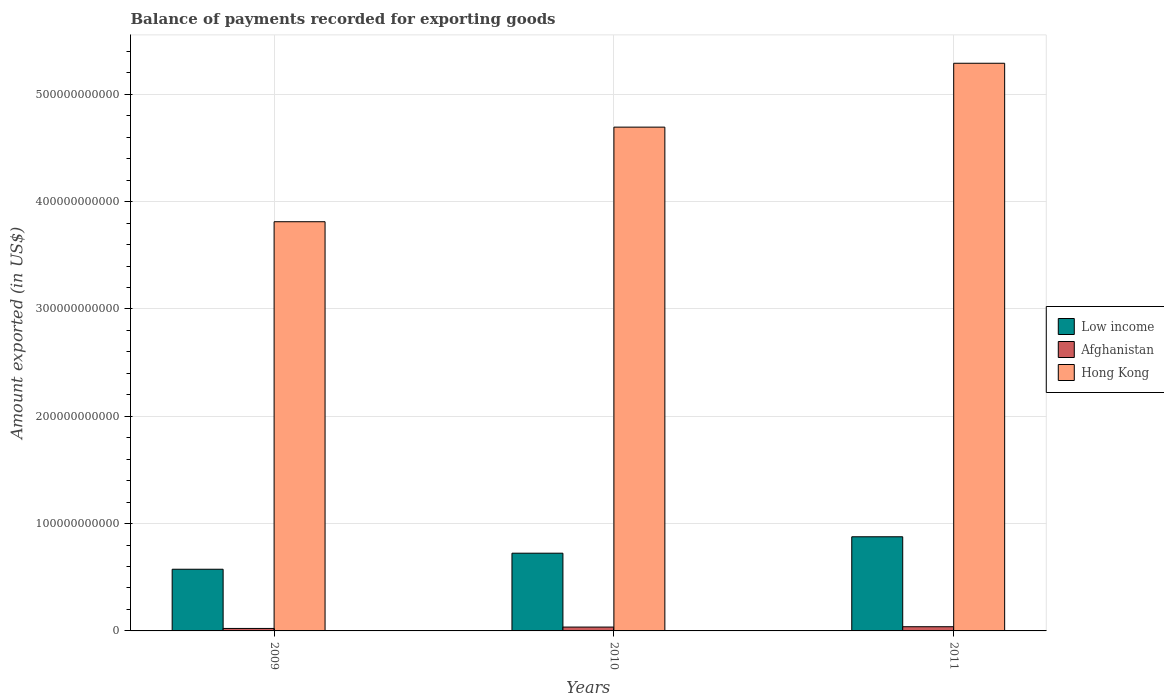How many groups of bars are there?
Keep it short and to the point. 3. How many bars are there on the 2nd tick from the left?
Provide a succinct answer. 3. In how many cases, is the number of bars for a given year not equal to the number of legend labels?
Make the answer very short. 0. What is the amount exported in Hong Kong in 2010?
Your answer should be very brief. 4.69e+11. Across all years, what is the maximum amount exported in Hong Kong?
Give a very brief answer. 5.29e+11. Across all years, what is the minimum amount exported in Hong Kong?
Ensure brevity in your answer.  3.81e+11. What is the total amount exported in Hong Kong in the graph?
Ensure brevity in your answer.  1.38e+12. What is the difference between the amount exported in Hong Kong in 2010 and that in 2011?
Offer a terse response. -5.95e+1. What is the difference between the amount exported in Hong Kong in 2011 and the amount exported in Low income in 2010?
Offer a very short reply. 4.57e+11. What is the average amount exported in Low income per year?
Your response must be concise. 7.25e+1. In the year 2011, what is the difference between the amount exported in Low income and amount exported in Hong Kong?
Make the answer very short. -4.41e+11. In how many years, is the amount exported in Hong Kong greater than 360000000000 US$?
Offer a terse response. 3. What is the ratio of the amount exported in Hong Kong in 2009 to that in 2010?
Your answer should be very brief. 0.81. Is the amount exported in Hong Kong in 2009 less than that in 2011?
Provide a succinct answer. Yes. What is the difference between the highest and the second highest amount exported in Hong Kong?
Make the answer very short. 5.95e+1. What is the difference between the highest and the lowest amount exported in Hong Kong?
Offer a very short reply. 1.48e+11. In how many years, is the amount exported in Hong Kong greater than the average amount exported in Hong Kong taken over all years?
Offer a very short reply. 2. What does the 3rd bar from the left in 2009 represents?
Make the answer very short. Hong Kong. What does the 2nd bar from the right in 2009 represents?
Make the answer very short. Afghanistan. How many bars are there?
Your answer should be very brief. 9. Are all the bars in the graph horizontal?
Your answer should be compact. No. What is the difference between two consecutive major ticks on the Y-axis?
Offer a terse response. 1.00e+11. Does the graph contain grids?
Provide a short and direct response. Yes. Where does the legend appear in the graph?
Ensure brevity in your answer.  Center right. What is the title of the graph?
Your answer should be very brief. Balance of payments recorded for exporting goods. Does "Mongolia" appear as one of the legend labels in the graph?
Your response must be concise. No. What is the label or title of the X-axis?
Your answer should be compact. Years. What is the label or title of the Y-axis?
Your response must be concise. Amount exported (in US$). What is the Amount exported (in US$) of Low income in 2009?
Keep it short and to the point. 5.75e+1. What is the Amount exported (in US$) in Afghanistan in 2009?
Your response must be concise. 2.30e+09. What is the Amount exported (in US$) in Hong Kong in 2009?
Your response must be concise. 3.81e+11. What is the Amount exported (in US$) of Low income in 2010?
Keep it short and to the point. 7.24e+1. What is the Amount exported (in US$) in Afghanistan in 2010?
Ensure brevity in your answer.  3.59e+09. What is the Amount exported (in US$) in Hong Kong in 2010?
Give a very brief answer. 4.69e+11. What is the Amount exported (in US$) in Low income in 2011?
Provide a succinct answer. 8.77e+1. What is the Amount exported (in US$) in Afghanistan in 2011?
Make the answer very short. 3.91e+09. What is the Amount exported (in US$) in Hong Kong in 2011?
Your answer should be very brief. 5.29e+11. Across all years, what is the maximum Amount exported (in US$) in Low income?
Make the answer very short. 8.77e+1. Across all years, what is the maximum Amount exported (in US$) of Afghanistan?
Offer a very short reply. 3.91e+09. Across all years, what is the maximum Amount exported (in US$) of Hong Kong?
Keep it short and to the point. 5.29e+11. Across all years, what is the minimum Amount exported (in US$) of Low income?
Ensure brevity in your answer.  5.75e+1. Across all years, what is the minimum Amount exported (in US$) in Afghanistan?
Give a very brief answer. 2.30e+09. Across all years, what is the minimum Amount exported (in US$) of Hong Kong?
Keep it short and to the point. 3.81e+11. What is the total Amount exported (in US$) in Low income in the graph?
Keep it short and to the point. 2.18e+11. What is the total Amount exported (in US$) in Afghanistan in the graph?
Offer a terse response. 9.80e+09. What is the total Amount exported (in US$) in Hong Kong in the graph?
Ensure brevity in your answer.  1.38e+12. What is the difference between the Amount exported (in US$) in Low income in 2009 and that in 2010?
Give a very brief answer. -1.50e+1. What is the difference between the Amount exported (in US$) of Afghanistan in 2009 and that in 2010?
Make the answer very short. -1.29e+09. What is the difference between the Amount exported (in US$) of Hong Kong in 2009 and that in 2010?
Your answer should be compact. -8.81e+1. What is the difference between the Amount exported (in US$) of Low income in 2009 and that in 2011?
Your answer should be compact. -3.03e+1. What is the difference between the Amount exported (in US$) in Afghanistan in 2009 and that in 2011?
Give a very brief answer. -1.61e+09. What is the difference between the Amount exported (in US$) of Hong Kong in 2009 and that in 2011?
Your answer should be very brief. -1.48e+11. What is the difference between the Amount exported (in US$) of Low income in 2010 and that in 2011?
Give a very brief answer. -1.53e+1. What is the difference between the Amount exported (in US$) of Afghanistan in 2010 and that in 2011?
Your answer should be very brief. -3.13e+08. What is the difference between the Amount exported (in US$) in Hong Kong in 2010 and that in 2011?
Offer a terse response. -5.95e+1. What is the difference between the Amount exported (in US$) in Low income in 2009 and the Amount exported (in US$) in Afghanistan in 2010?
Offer a terse response. 5.39e+1. What is the difference between the Amount exported (in US$) of Low income in 2009 and the Amount exported (in US$) of Hong Kong in 2010?
Keep it short and to the point. -4.12e+11. What is the difference between the Amount exported (in US$) of Afghanistan in 2009 and the Amount exported (in US$) of Hong Kong in 2010?
Your answer should be compact. -4.67e+11. What is the difference between the Amount exported (in US$) of Low income in 2009 and the Amount exported (in US$) of Afghanistan in 2011?
Ensure brevity in your answer.  5.36e+1. What is the difference between the Amount exported (in US$) of Low income in 2009 and the Amount exported (in US$) of Hong Kong in 2011?
Your response must be concise. -4.71e+11. What is the difference between the Amount exported (in US$) of Afghanistan in 2009 and the Amount exported (in US$) of Hong Kong in 2011?
Provide a succinct answer. -5.27e+11. What is the difference between the Amount exported (in US$) in Low income in 2010 and the Amount exported (in US$) in Afghanistan in 2011?
Ensure brevity in your answer.  6.85e+1. What is the difference between the Amount exported (in US$) in Low income in 2010 and the Amount exported (in US$) in Hong Kong in 2011?
Offer a terse response. -4.57e+11. What is the difference between the Amount exported (in US$) of Afghanistan in 2010 and the Amount exported (in US$) of Hong Kong in 2011?
Your answer should be compact. -5.25e+11. What is the average Amount exported (in US$) of Low income per year?
Offer a very short reply. 7.25e+1. What is the average Amount exported (in US$) of Afghanistan per year?
Your answer should be very brief. 3.27e+09. What is the average Amount exported (in US$) in Hong Kong per year?
Give a very brief answer. 4.60e+11. In the year 2009, what is the difference between the Amount exported (in US$) of Low income and Amount exported (in US$) of Afghanistan?
Make the answer very short. 5.52e+1. In the year 2009, what is the difference between the Amount exported (in US$) in Low income and Amount exported (in US$) in Hong Kong?
Your answer should be very brief. -3.24e+11. In the year 2009, what is the difference between the Amount exported (in US$) in Afghanistan and Amount exported (in US$) in Hong Kong?
Provide a succinct answer. -3.79e+11. In the year 2010, what is the difference between the Amount exported (in US$) of Low income and Amount exported (in US$) of Afghanistan?
Your response must be concise. 6.88e+1. In the year 2010, what is the difference between the Amount exported (in US$) of Low income and Amount exported (in US$) of Hong Kong?
Give a very brief answer. -3.97e+11. In the year 2010, what is the difference between the Amount exported (in US$) of Afghanistan and Amount exported (in US$) of Hong Kong?
Your answer should be very brief. -4.66e+11. In the year 2011, what is the difference between the Amount exported (in US$) of Low income and Amount exported (in US$) of Afghanistan?
Give a very brief answer. 8.38e+1. In the year 2011, what is the difference between the Amount exported (in US$) in Low income and Amount exported (in US$) in Hong Kong?
Your response must be concise. -4.41e+11. In the year 2011, what is the difference between the Amount exported (in US$) of Afghanistan and Amount exported (in US$) of Hong Kong?
Provide a succinct answer. -5.25e+11. What is the ratio of the Amount exported (in US$) in Low income in 2009 to that in 2010?
Offer a terse response. 0.79. What is the ratio of the Amount exported (in US$) of Afghanistan in 2009 to that in 2010?
Keep it short and to the point. 0.64. What is the ratio of the Amount exported (in US$) of Hong Kong in 2009 to that in 2010?
Give a very brief answer. 0.81. What is the ratio of the Amount exported (in US$) in Low income in 2009 to that in 2011?
Keep it short and to the point. 0.66. What is the ratio of the Amount exported (in US$) of Afghanistan in 2009 to that in 2011?
Your answer should be very brief. 0.59. What is the ratio of the Amount exported (in US$) in Hong Kong in 2009 to that in 2011?
Give a very brief answer. 0.72. What is the ratio of the Amount exported (in US$) in Low income in 2010 to that in 2011?
Offer a terse response. 0.83. What is the ratio of the Amount exported (in US$) of Afghanistan in 2010 to that in 2011?
Your answer should be very brief. 0.92. What is the ratio of the Amount exported (in US$) in Hong Kong in 2010 to that in 2011?
Provide a short and direct response. 0.89. What is the difference between the highest and the second highest Amount exported (in US$) in Low income?
Provide a short and direct response. 1.53e+1. What is the difference between the highest and the second highest Amount exported (in US$) of Afghanistan?
Offer a very short reply. 3.13e+08. What is the difference between the highest and the second highest Amount exported (in US$) of Hong Kong?
Give a very brief answer. 5.95e+1. What is the difference between the highest and the lowest Amount exported (in US$) of Low income?
Offer a terse response. 3.03e+1. What is the difference between the highest and the lowest Amount exported (in US$) in Afghanistan?
Provide a succinct answer. 1.61e+09. What is the difference between the highest and the lowest Amount exported (in US$) of Hong Kong?
Your response must be concise. 1.48e+11. 